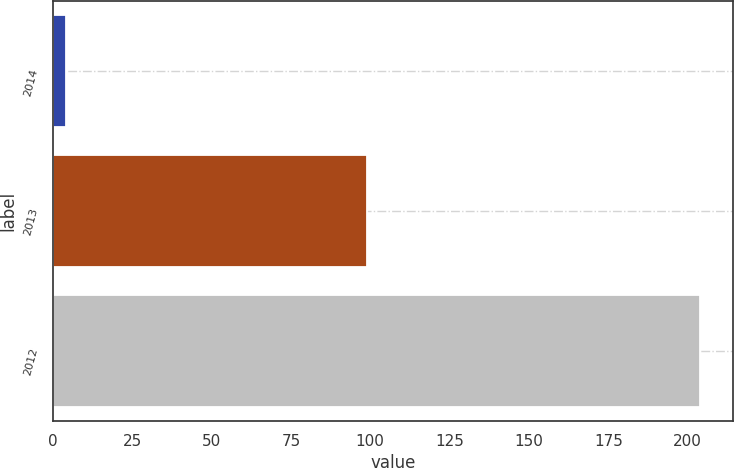Convert chart to OTSL. <chart><loc_0><loc_0><loc_500><loc_500><bar_chart><fcel>2014<fcel>2013<fcel>2012<nl><fcel>4<fcel>99<fcel>204<nl></chart> 